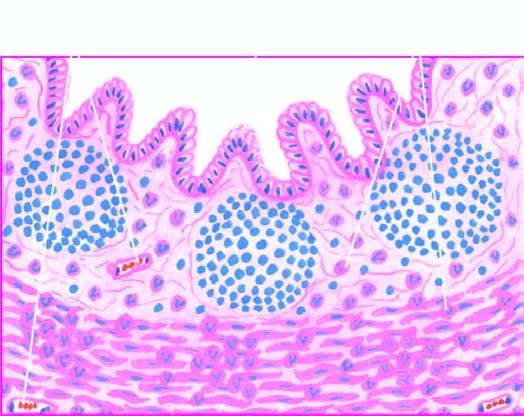what are other changes present?
Answer the question using a single word or phrase. Necrosis of mucosa and periappendicitis 